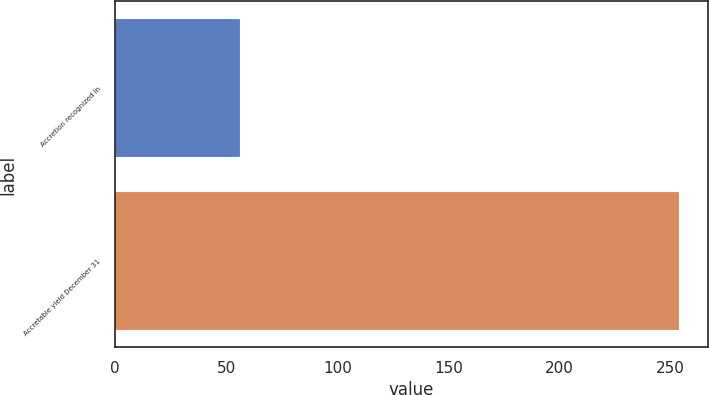Convert chart. <chart><loc_0><loc_0><loc_500><loc_500><bar_chart><fcel>Accretion recognized in<fcel>Accretable yield December 31<nl><fcel>56<fcel>254<nl></chart> 